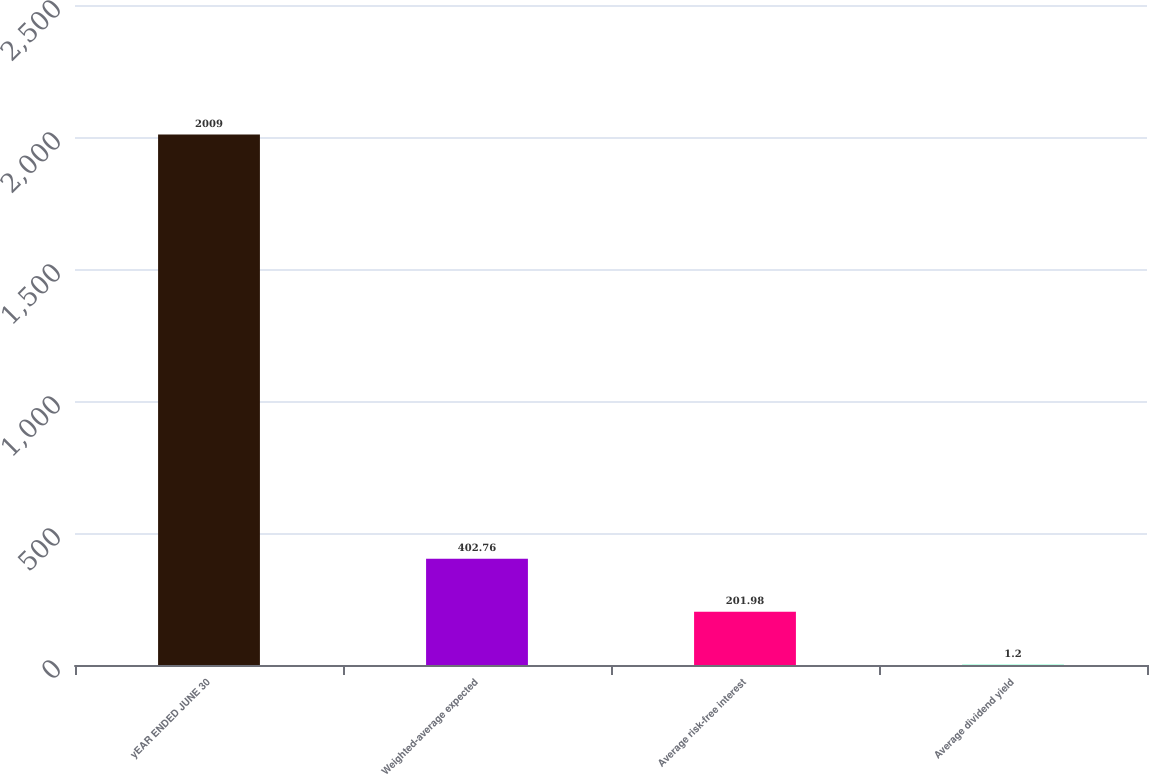<chart> <loc_0><loc_0><loc_500><loc_500><bar_chart><fcel>yEAR ENDED JUNE 30<fcel>Weighted-average expected<fcel>Average risk-free interest<fcel>Average dividend yield<nl><fcel>2009<fcel>402.76<fcel>201.98<fcel>1.2<nl></chart> 